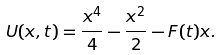Convert formula to latex. <formula><loc_0><loc_0><loc_500><loc_500>U ( x , t ) = \frac { x ^ { 4 } } { 4 } - \frac { x ^ { 2 } } { 2 } - F ( t ) x .</formula> 